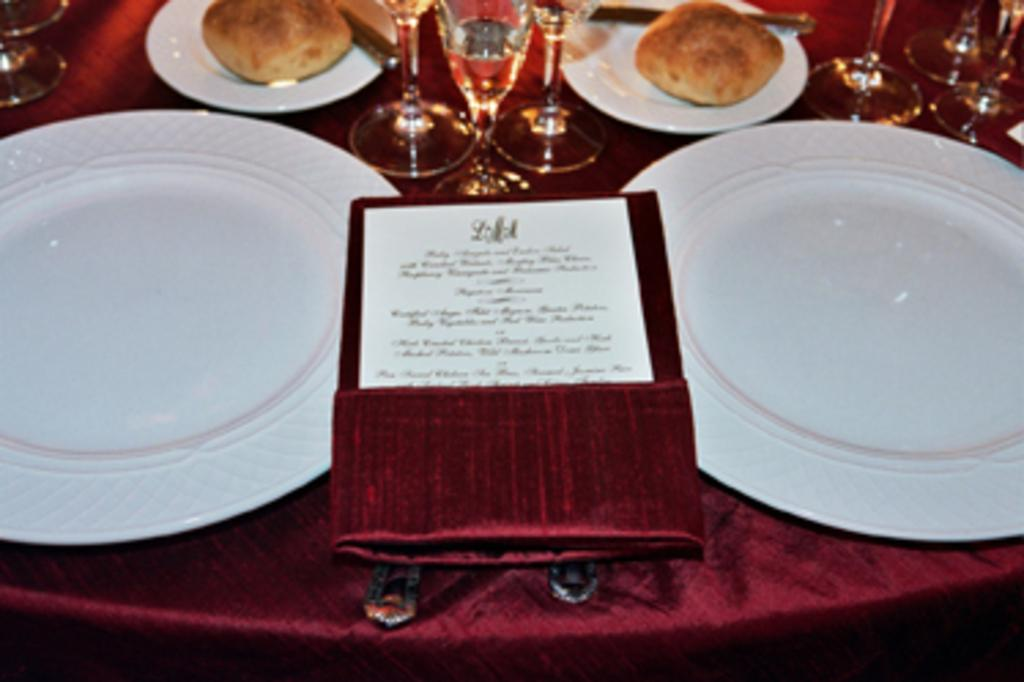What type of objects can be seen in the image? There are plates, food items, glasses, a paper, and other objects in the image. How are these objects arranged in the image? All these items are placed on a cloth. Can you describe the food items in the image? The food items are not specified, but they are present in the image. What else can be seen in the image besides the mentioned objects? There are other objects in the image, but their specific details are not provided. Are there any plantations visible in the image? There is no mention of a plantation in the image, so it cannot be determined from the provided facts. What type of poison is present in the image? There is no mention of poison in the image, so it cannot be determined from the provided facts. 